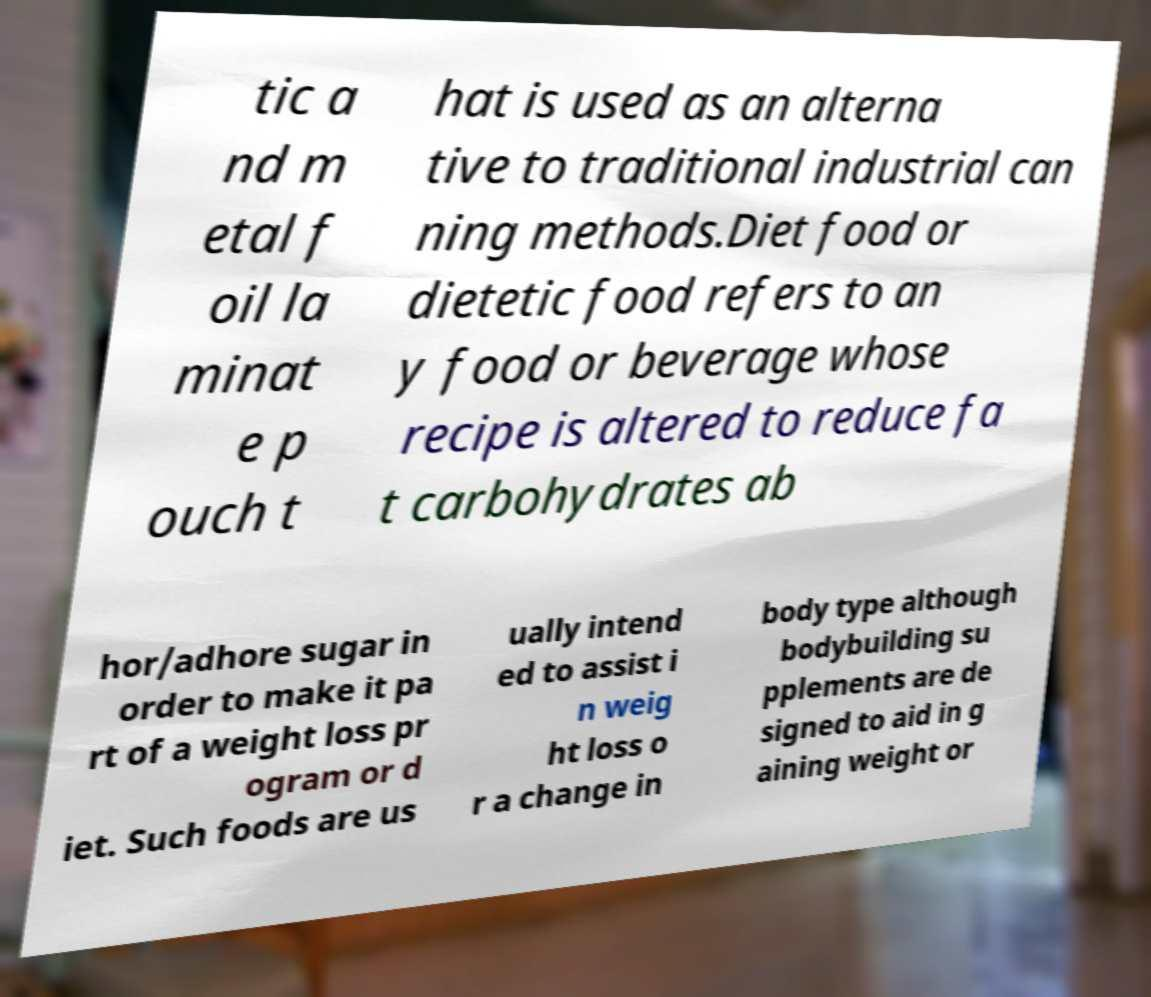Please identify and transcribe the text found in this image. tic a nd m etal f oil la minat e p ouch t hat is used as an alterna tive to traditional industrial can ning methods.Diet food or dietetic food refers to an y food or beverage whose recipe is altered to reduce fa t carbohydrates ab hor/adhore sugar in order to make it pa rt of a weight loss pr ogram or d iet. Such foods are us ually intend ed to assist i n weig ht loss o r a change in body type although bodybuilding su pplements are de signed to aid in g aining weight or 